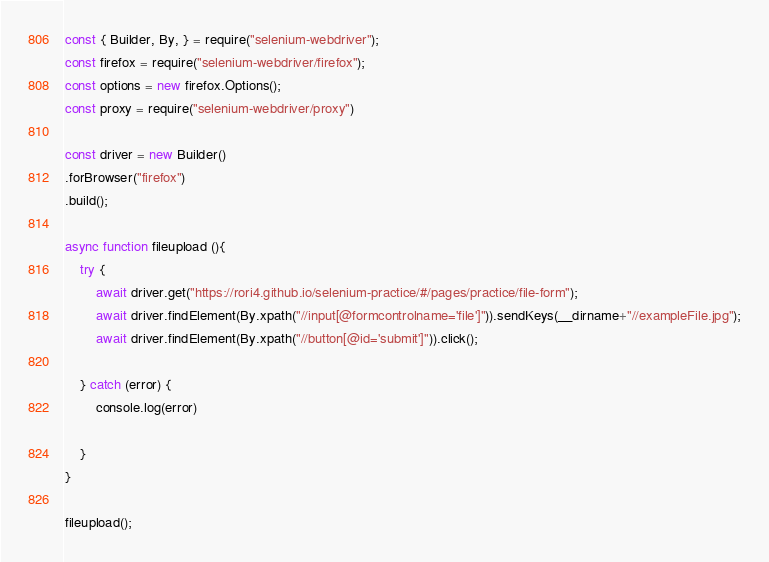Convert code to text. <code><loc_0><loc_0><loc_500><loc_500><_JavaScript_>const { Builder, By, } = require("selenium-webdriver");
const firefox = require("selenium-webdriver/firefox");
const options = new firefox.Options();
const proxy = require("selenium-webdriver/proxy")

const driver = new Builder()
.forBrowser("firefox")
.build();

async function fileupload (){
    try {
        await driver.get("https://rori4.github.io/selenium-practice/#/pages/practice/file-form");
        await driver.findElement(By.xpath("//input[@formcontrolname='file']")).sendKeys(__dirname+"//exampleFile.jpg");
        await driver.findElement(By.xpath("//button[@id='submit']")).click();
        
    } catch (error) {
        console.log(error)
        
    }
}

fileupload();</code> 